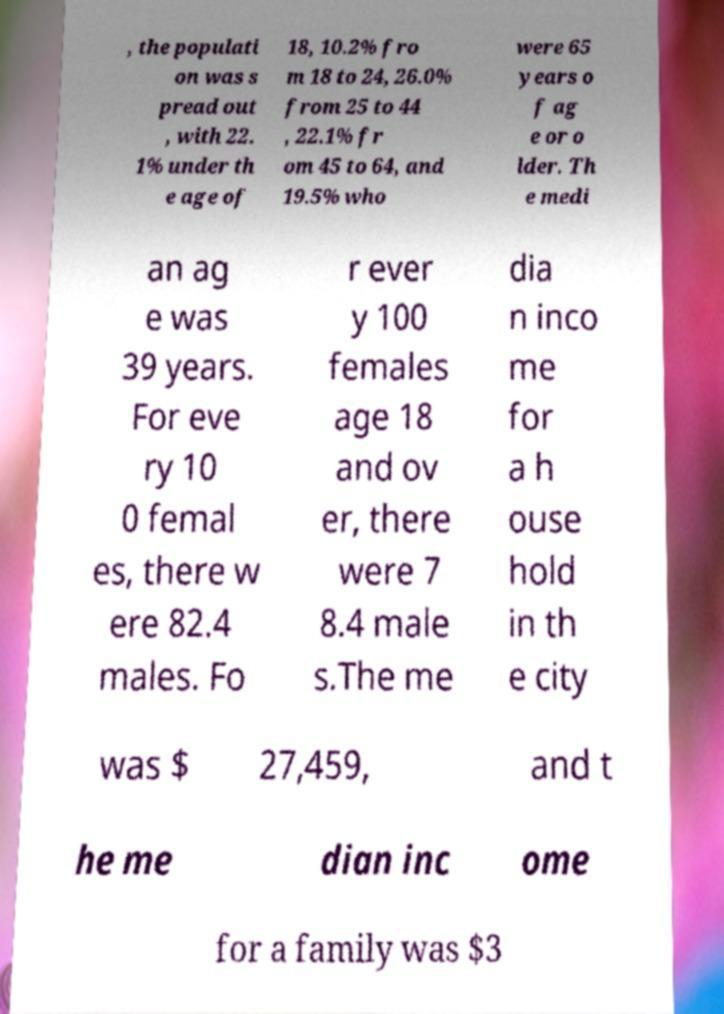There's text embedded in this image that I need extracted. Can you transcribe it verbatim? , the populati on was s pread out , with 22. 1% under th e age of 18, 10.2% fro m 18 to 24, 26.0% from 25 to 44 , 22.1% fr om 45 to 64, and 19.5% who were 65 years o f ag e or o lder. Th e medi an ag e was 39 years. For eve ry 10 0 femal es, there w ere 82.4 males. Fo r ever y 100 females age 18 and ov er, there were 7 8.4 male s.The me dia n inco me for a h ouse hold in th e city was $ 27,459, and t he me dian inc ome for a family was $3 